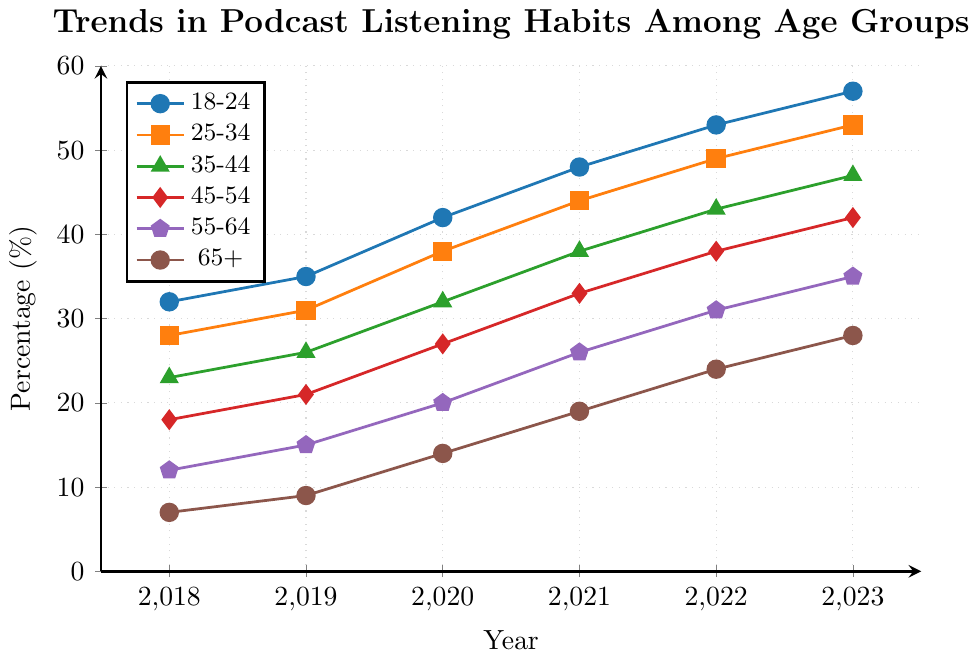What trend can be observed for the 18-24 age group from 2018 to 2023? To determine the trend, observe the visual increase in the percentage values for the 18-24 age group across the years. It starts at 32% in 2018 and increases steadily each year, reaching 57% in 2023.
Answer: Increasing trend Which age group had the lowest percentage of podcast listeners in 2020? Identify the age group with the lowest value in 2020. The 65+ age group had 14%, the lowest among all age groups in that year.
Answer: 65+ How much has the percentage of podcast listeners in the 45-54 age group increased from 2018 to 2023? Subtract the percentage in 2018 from the percentage in 2023 for the 45-54 age group: 42% - 18% = 24%.
Answer: 24% Which two age groups have the most similar listening percentages in 2022? Compare the percentages for all age groups in 2022. The 18-24 group has 53%, and the 25-34 group has 49%, which are the most similar values (difference of 4%).
Answer: 18-24 and 25-34 For which year does the 25-34 age group show the greatest increase in percentage over the previous year? Calculate the yearly increments for the 25-34 age group: 
2018 to 2019: 31 - 28 = 3,
2019 to 2020: 38 - 31 = 7,
2020 to 2021: 44 - 38 = 6,
2021 to 2022: 49 - 44 = 5,
2022 to 2023: 53 - 49 = 4.
The greatest increase is from 2019 to 2020 with a value of 7%.
Answer: 2020 Which age group shows the steepest increase in podcast listening from 2021 to 2023? Evaluate the increase for each age group from 2021 to 2023:
18-24: 57 - 48 = 9,
25-34: 53 - 44 = 9,
35-44: 47 - 38 = 9,
45-54: 42 - 33 = 9,
55-64: 35 - 26 = 9,
65+: 28 - 19 = 9.
All age groups show an equal increase of 9%.
Answer: All age groups What was the percentage of podcast listeners for the 18-24 and 65+ age groups combined in 2023? Add the percentages for the 18-24 and 65+ age groups in 2023: 57% + 28% = 85%.
Answer: 85% Which age group had the highest percentage of podcast listeners in 2018, and what was the percentage? Check the values for each age group in 2018. The 18-24 age group had the highest percentage at 32%.
Answer: 18-24, 32% How does the growth rate in the percentage of podcast listeners in the 55-64 age group from 2018 to 2023 compare to the 18-24 age group in the same period? Calculate the growth rates for both groups: 
55-64 from 2018 to 2023: (35 - 12) / 12 = 1.92 (or 192%),
18-24 from 2018 to 2023: (57 - 32) / 32 = 0.78 (or 78%).
The 55-64 age group grew at a higher rate of 192% compared to 78% for the 18-24 age group.
Answer: 55-64 grew faster (192% vs. 78%) 